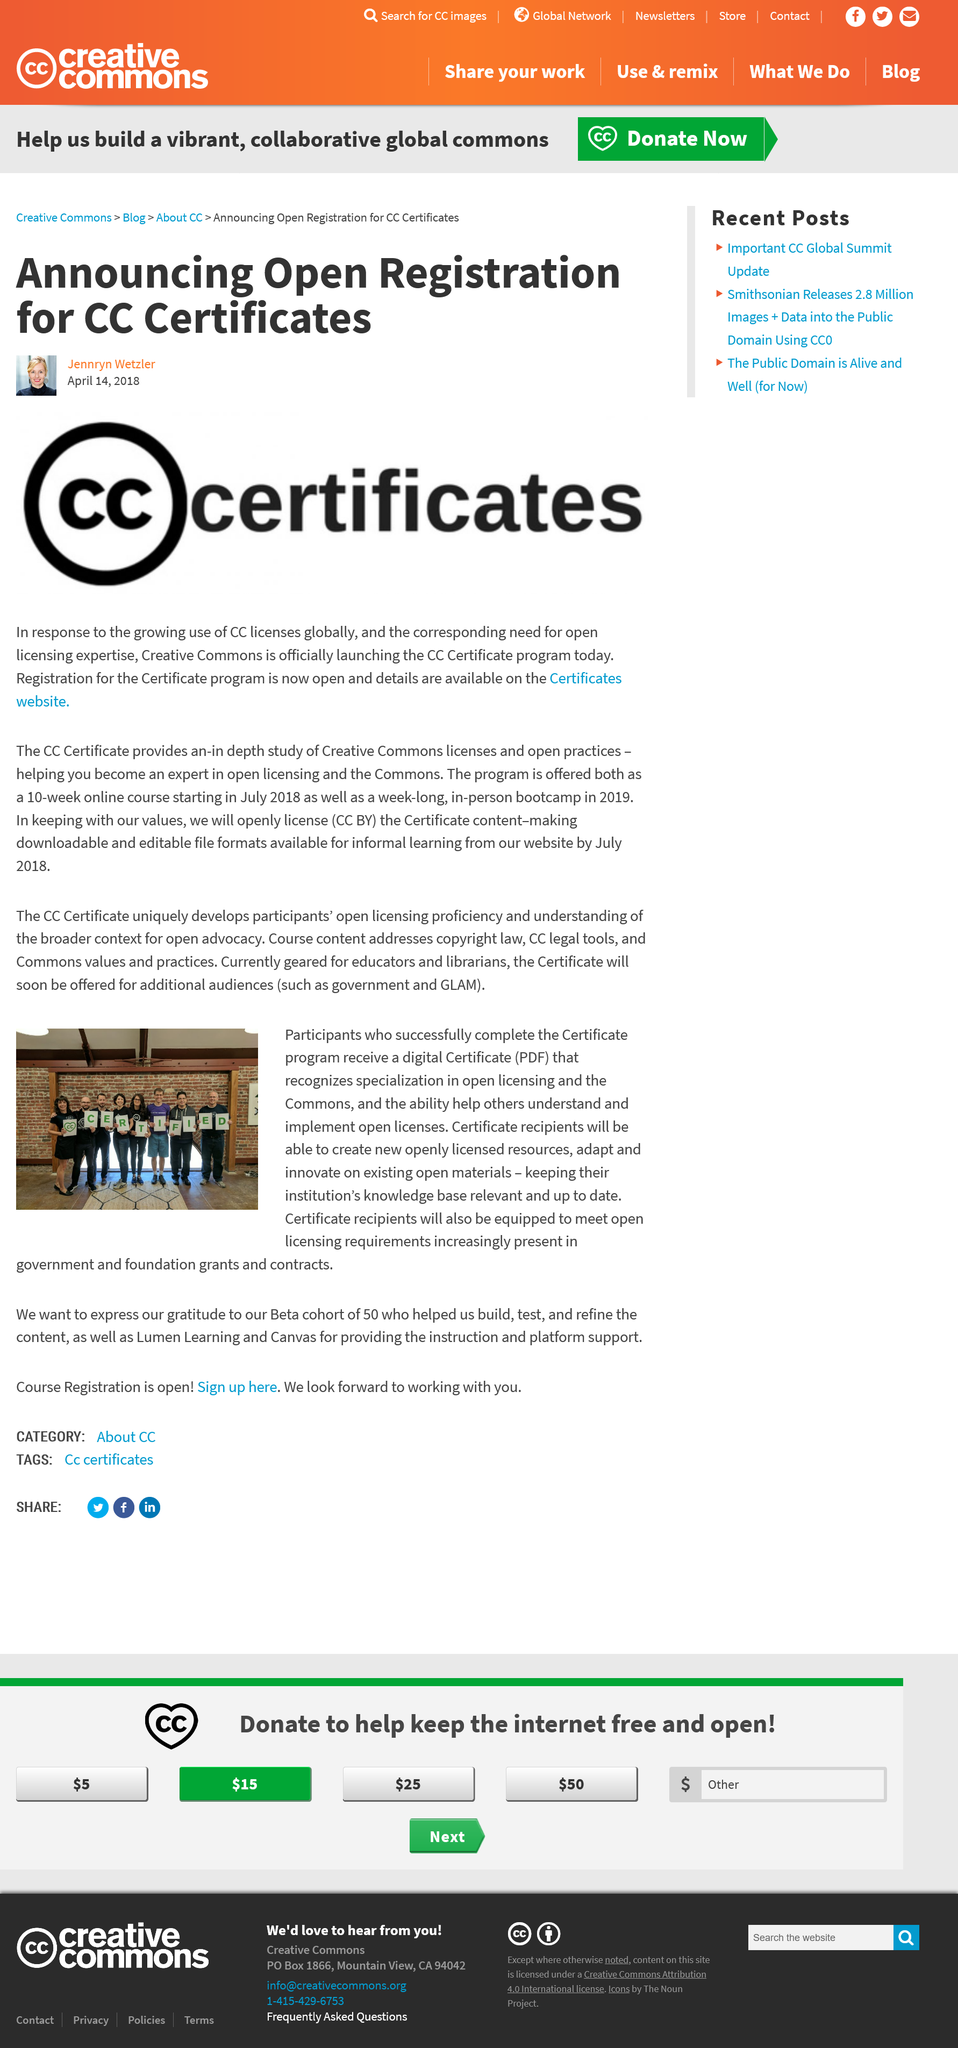Highlight a few significant elements in this photo. This program will enable participants to update and enhance their institution's knowledge base by creating new openly licensed resources and adapting existing ones, ensuring that their institution remains relevant and up-to-date in their field. CC is launching the CC Certificate program. The online course spans 10 weeks. Upon completion of the certificate program, participants will receive a digital certificate recognizing their specialization in open licensing and the commons, as well as their ability to assist others in understanding and implementing open licenses. The program is designed to enhance an individual's expertise in open licensing and the Commons, thereby making them proficient in utilizing these tools effectively. 